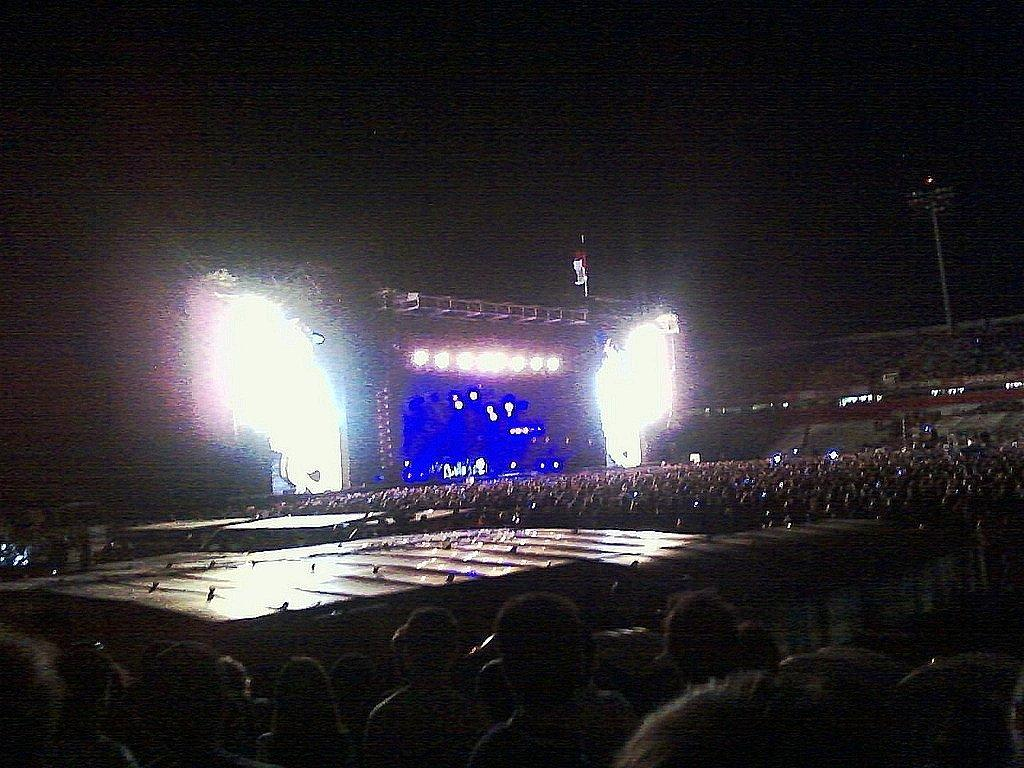Who or what can be seen in the image? There are people in the image. What is located in the background of the image? There is a screen and lights in the background of the image. Can you describe the object on the right side of the image? There is a pole on the right side of the image. How would you describe the overall lighting in the image? The background of the image is dark. What type of clam is being used as a prop in the image? There is no clam present in the image. Is the sleet visible in the image? The image does not show any sleet; it only shows people, a screen, lights, a pole, and a dark background. 